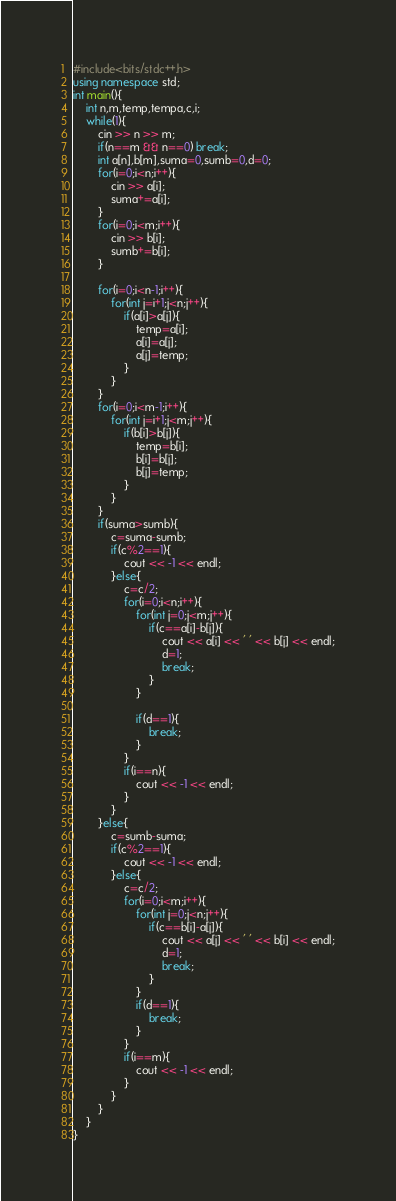<code> <loc_0><loc_0><loc_500><loc_500><_C++_>#include<bits/stdc++.h>
using namespace std;
int main(){
	int n,m,temp,tempa,c,i;
	while(1){
		cin >> n >> m;
		if(n==m && n==0) break;
		int a[n],b[m],suma=0,sumb=0,d=0;
		for(i=0;i<n;i++){
			cin >> a[i];
			suma+=a[i];
		}
		for(i=0;i<m;i++){
			cin >> b[i];
			sumb+=b[i];
		}
		
		for(i=0;i<n-1;i++){
			for(int j=i+1;j<n;j++){
				if(a[i]>a[j]){
					temp=a[i];
					a[i]=a[j];
					a[j]=temp;
				}
			}
		}
		for(i=0;i<m-1;i++){
			for(int j=i+1;j<m;j++){
				if(b[i]>b[j]){
					temp=b[i];
					b[i]=b[j];
					b[j]=temp;
				}
			}
		}
		if(suma>sumb){
			c=suma-sumb;
			if(c%2==1){
				cout << -1 << endl;
			}else{
				c=c/2;
				for(i=0;i<n;i++){
					for(int j=0;j<m;j++){
						if(c==a[i]-b[j]){
							cout << a[i] << ' ' << b[j] << endl;
							d=1;
							break;
						}
					}
		
					if(d==1){
						break;
					}
				}
				if(i==n){
					cout << -1 << endl;
				}
			}
		}else{
			c=sumb-suma;
			if(c%2==1){
				cout << -1 << endl;
			}else{
				c=c/2;
				for(i=0;i<m;i++){
					for(int j=0;j<n;j++){
						if(c==b[i]-a[j]){
							cout << a[j] << ' ' << b[i] << endl;
							d=1;
							break;
						}
					}
					if(d==1){
						break;
					}
				}
				if(i==m){
					cout << -1 << endl;
				}
			}
		}
	}
}
</code> 